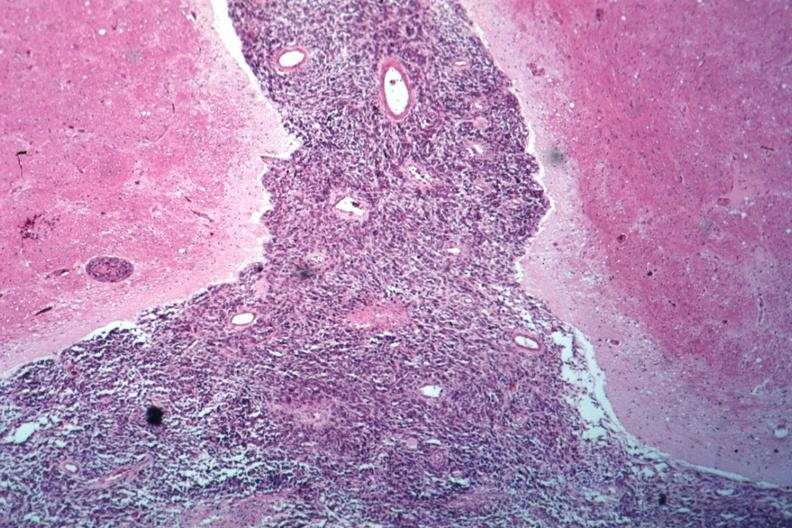what is present?
Answer the question using a single word or phrase. Brain 